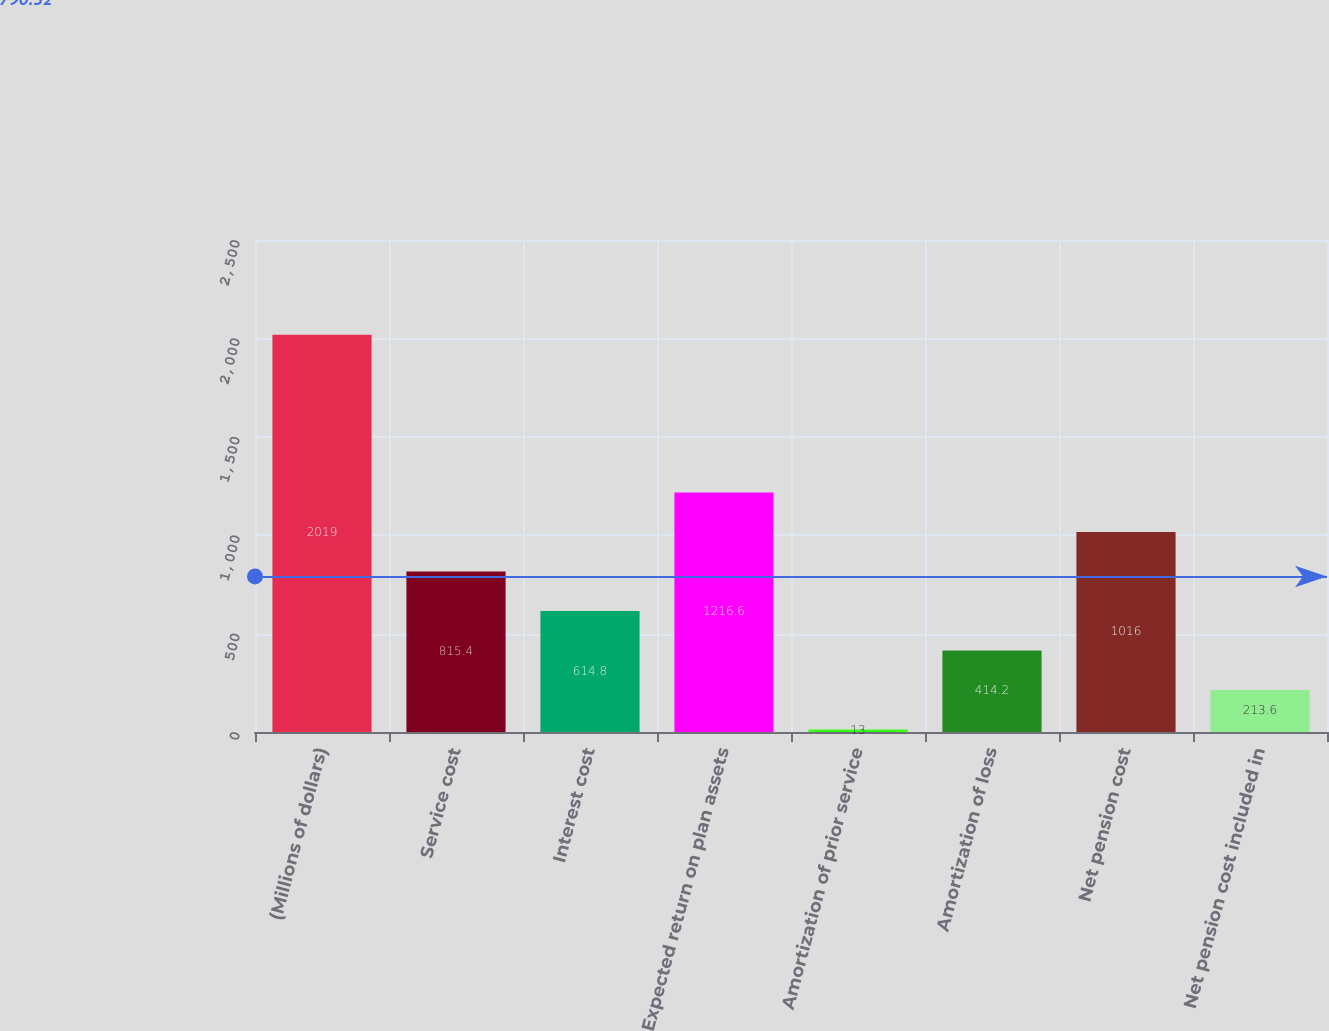<chart> <loc_0><loc_0><loc_500><loc_500><bar_chart><fcel>(Millions of dollars)<fcel>Service cost<fcel>Interest cost<fcel>Expected return on plan assets<fcel>Amortization of prior service<fcel>Amortization of loss<fcel>Net pension cost<fcel>Net pension cost included in<nl><fcel>2019<fcel>815.4<fcel>614.8<fcel>1216.6<fcel>13<fcel>414.2<fcel>1016<fcel>213.6<nl></chart> 